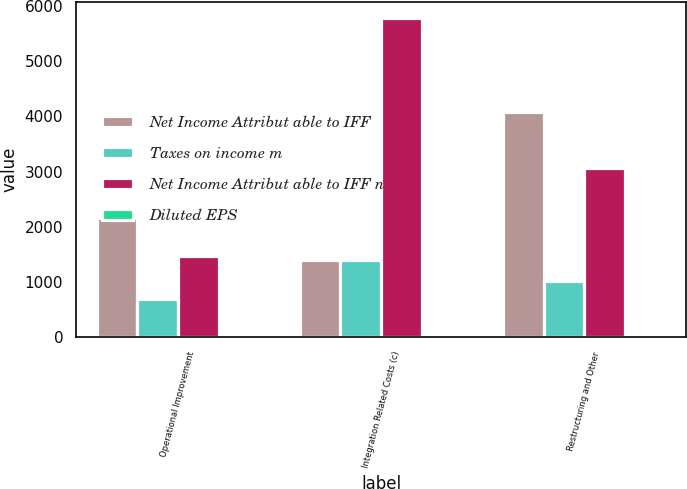Convert chart to OTSL. <chart><loc_0><loc_0><loc_500><loc_500><stacked_bar_chart><ecel><fcel>Operational Improvement<fcel>Integration Related Costs (c)<fcel>Restructuring and Other<nl><fcel>Net Income Attribut able to IFF<fcel>2169<fcel>1397<fcel>4086<nl><fcel>Taxes on income m<fcel>694<fcel>1397<fcel>1020<nl><fcel>Net Income Attribut able to IFF n<fcel>1475<fcel>5791<fcel>3066<nl><fcel>Diluted EPS<fcel>0.02<fcel>0.07<fcel>0.03<nl></chart> 